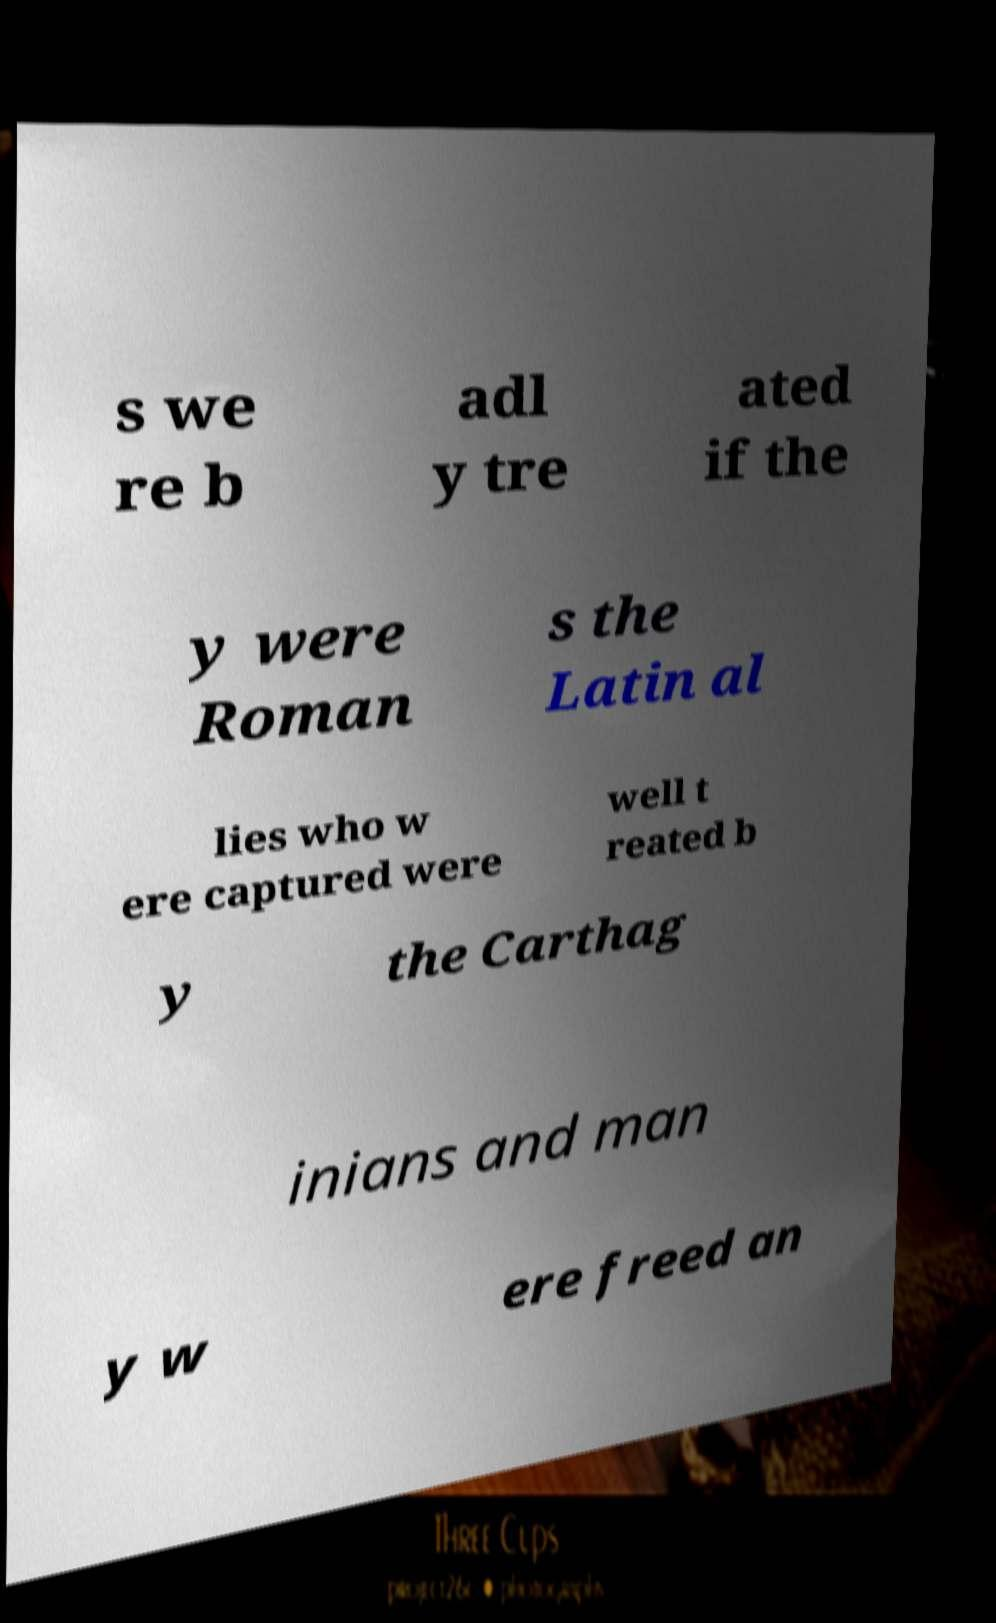Can you read and provide the text displayed in the image?This photo seems to have some interesting text. Can you extract and type it out for me? s we re b adl y tre ated if the y were Roman s the Latin al lies who w ere captured were well t reated b y the Carthag inians and man y w ere freed an 